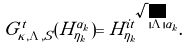Convert formula to latex. <formula><loc_0><loc_0><loc_500><loc_500>G _ { \tilde { \kappa } , \Lambda , S } ^ { t } ( H _ { \eta _ { k } } ^ { \alpha _ { k } } ) = H _ { \eta _ { k } } ^ { i t \sqrt { | \Lambda | } \alpha _ { k } } .</formula> 